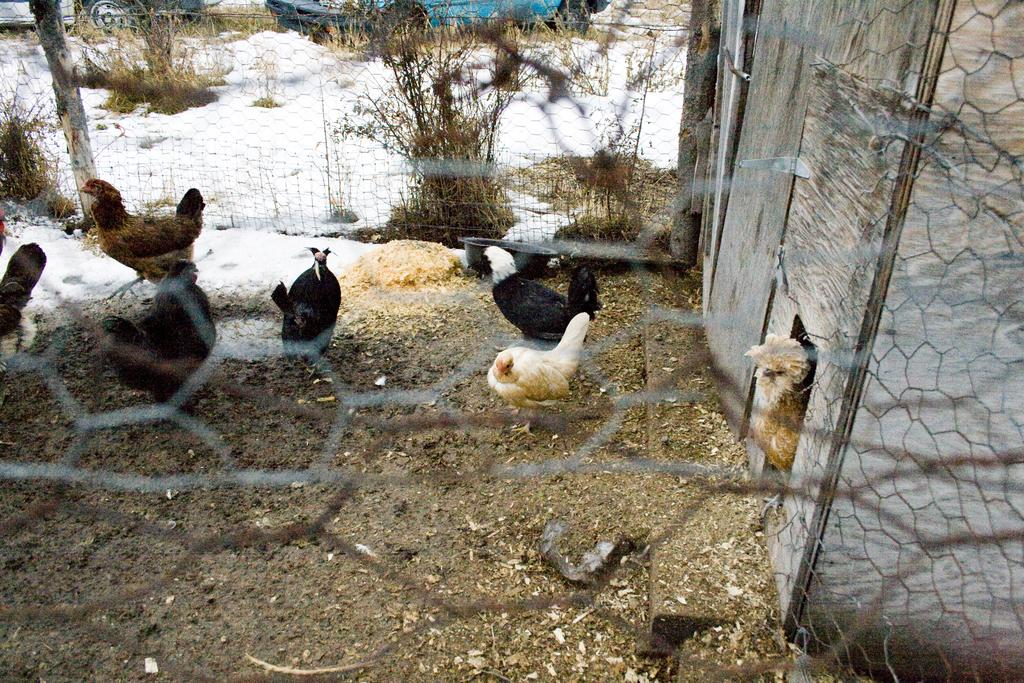What is located in the foreground of the image? There is a mesh in the foreground of the image. What type of animals can be seen in the image? There are hens in the image. What else is present in the image besides the hens? There are plants in the image. What is the weather condition in the image? It appears to be snow in the image. What can be seen in the background of the image? There is a vehicle in the background of the image. What type of pan is being used to settle the argument in the image? There is no pan or argument present in the image. 